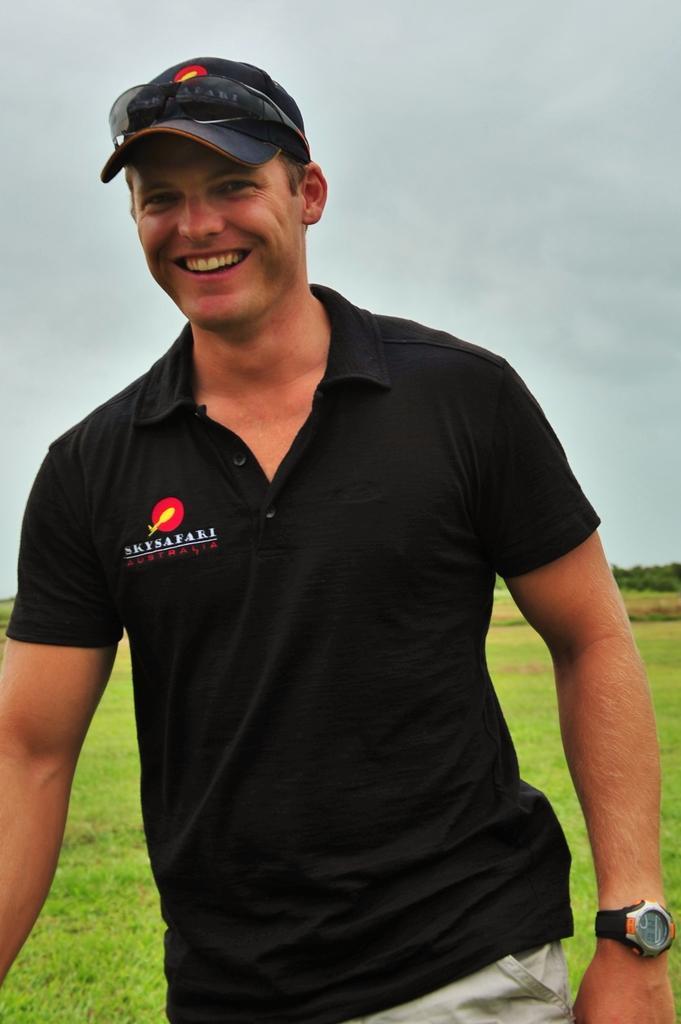How would you summarize this image in a sentence or two? In this picture I can see a man is standing and smiling. The man is wearing a cap, shares, a black color t-shirt and a watch. In the background I can see grass, trees and the sky. 